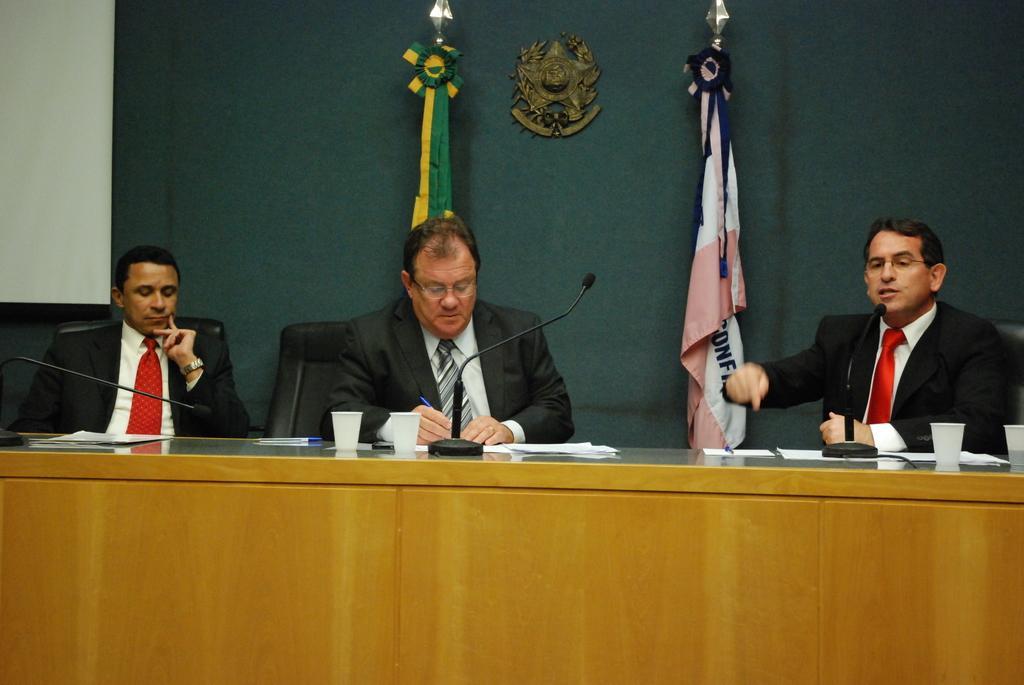Please provide a concise description of this image. In this image we can see three persons sitting on chairs. There is a platform with cups, mics, papers and some other items. In the back there are flags. In the background there is a wall with an emblem. 